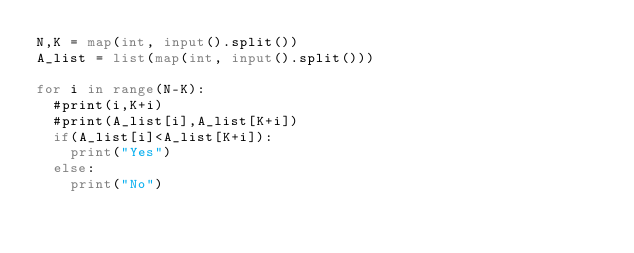<code> <loc_0><loc_0><loc_500><loc_500><_Python_>N,K = map(int, input().split())
A_list = list(map(int, input().split()))

for i in range(N-K):
  #print(i,K+i)
  #print(A_list[i],A_list[K+i])
  if(A_list[i]<A_list[K+i]):
    print("Yes")
  else:
    print("No")</code> 